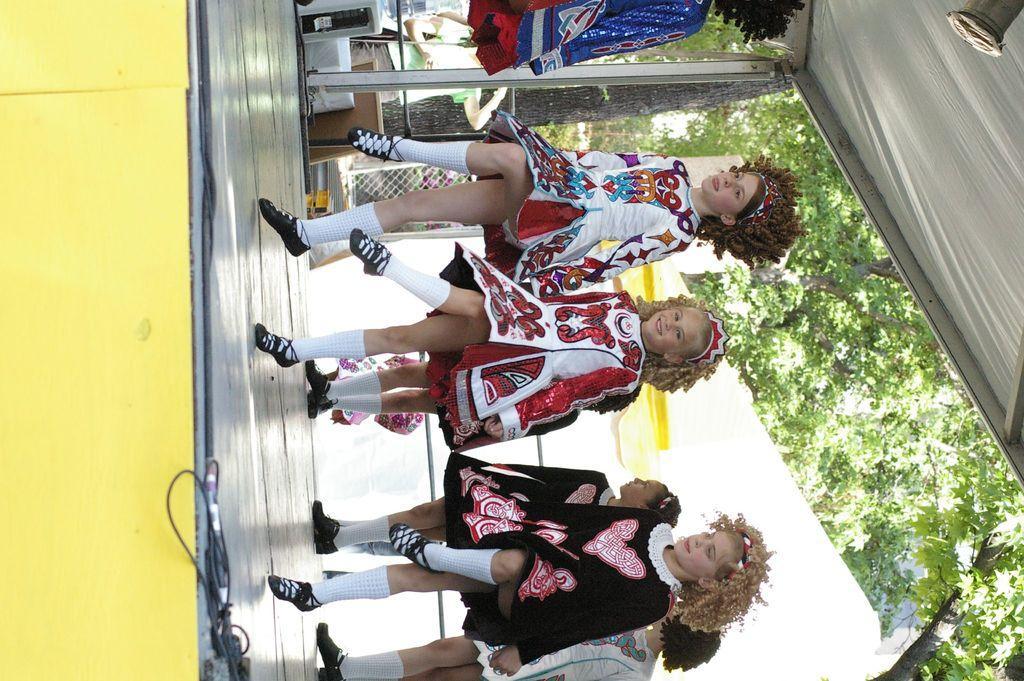Please provide a concise description of this image. In this picture I can see a group of children are dancing on the stage, on the right side there are trees. 